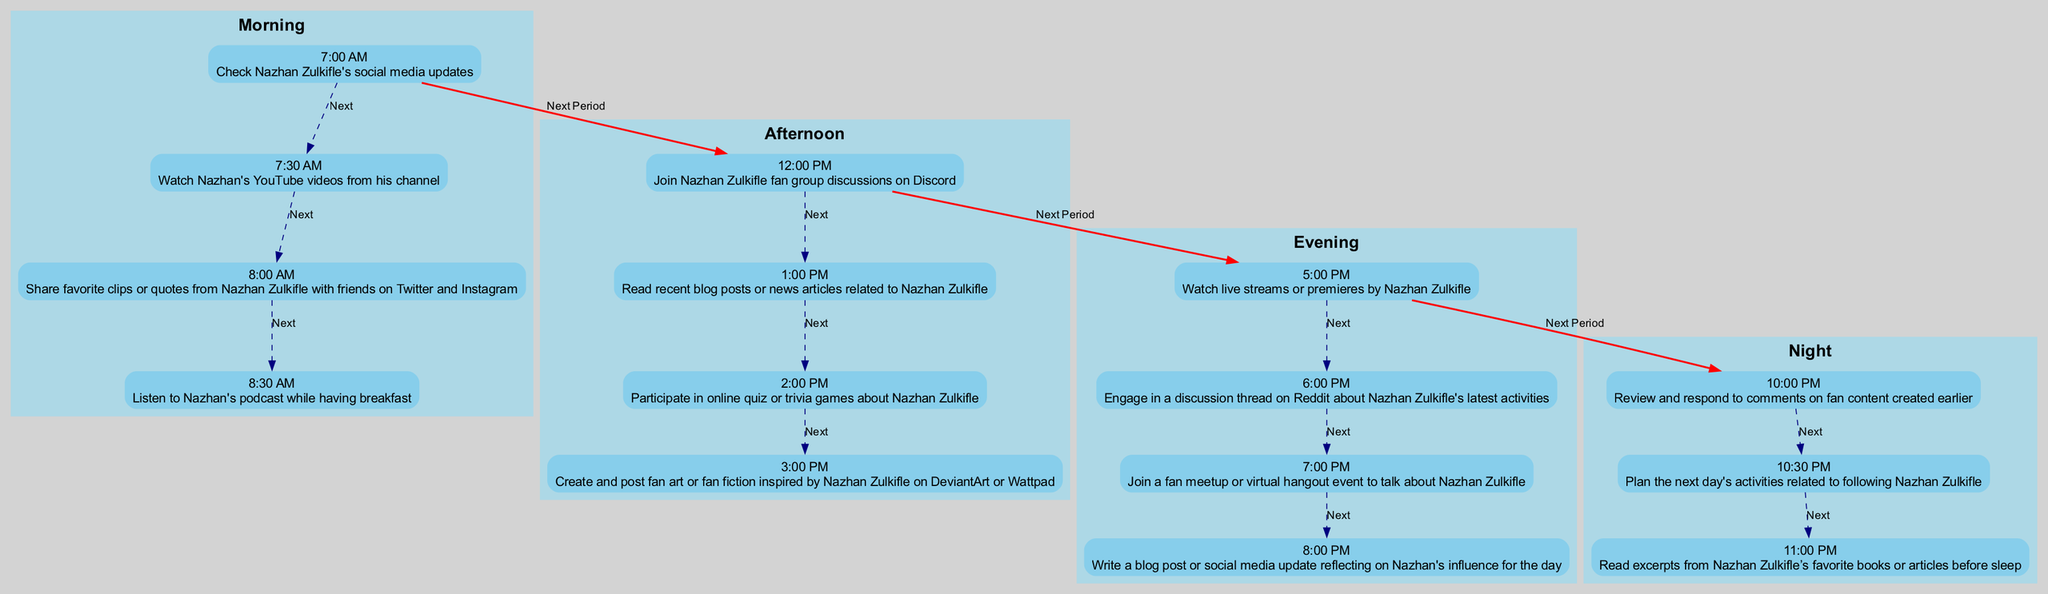What activity starts the morning for a Nazhan Zulkifle fan? The first activity listed in the morning section is "Check Nazhan Zulkifle's social media updates" at 7:00 AM. This means that the fan's day begins with this task.
Answer: Check Nazhan Zulkifle's social media updates At what time does the fan listen to Nazhan's podcast? According to the diagram, the fan listens to Nazhan's podcast at 8:30 AM. This is indicated as the fourth activity in the morning section.
Answer: 8:30 AM What activity occurs at 5:00 PM? The diagram shows that at 5:00 PM, the activity is "Watch live streams or premieres by Nazhan Zulkifle." This is a straightforward extraction from the evening section of the diagram.
Answer: Watch live streams or premieres by Nazhan Zulkifle How many activities are listed in the afternoon section? The afternoon section contains four activities: joining fan group discussions, reading blog posts or articles, participating in trivia games, and creating fan art. Thus, there are four activities listed.
Answer: Four What connects the morning and afternoon activities? The first node in the morning (7:00 AM) connects to the first node in the afternoon (12:00 PM) with a "Next Period" edge indicating a transition from morning to afternoon activities.
Answer: Next Period Which social media platforms does the fan use to share content? The fan shares favorite clips or quotes on Twitter and Instagram as mentioned in the 8:00 AM activity. This indicates the platforms used for sharing.
Answer: Twitter and Instagram What is the last activity of the night section? The night section ends with the activity "Read excerpts from Nazhan Zulkifle’s favorite books or articles before sleep," which is scheduled for 11:00 PM. This is the final activity noted in that section.
Answer: Read excerpts from Nazhan Zulkifle’s favorite books or articles before sleep What is the nature of the activities in the evening section compared to the morning section? The activities in the evening section primarily focus on live interaction, such as live streams, discussions, and meetups, while the morning consists more of content consumption and sharing. This indicates a shift from passive to interactive engagement in the fan's routine.
Answer: More interactive activities What is the earliest activity listed in the daily routine? The earliest activity is "Check Nazhan Zulkifle's social media updates," scheduled at 7:00 AM, marking the start of the day.
Answer: Check Nazhan Zulkifle's social media updates 